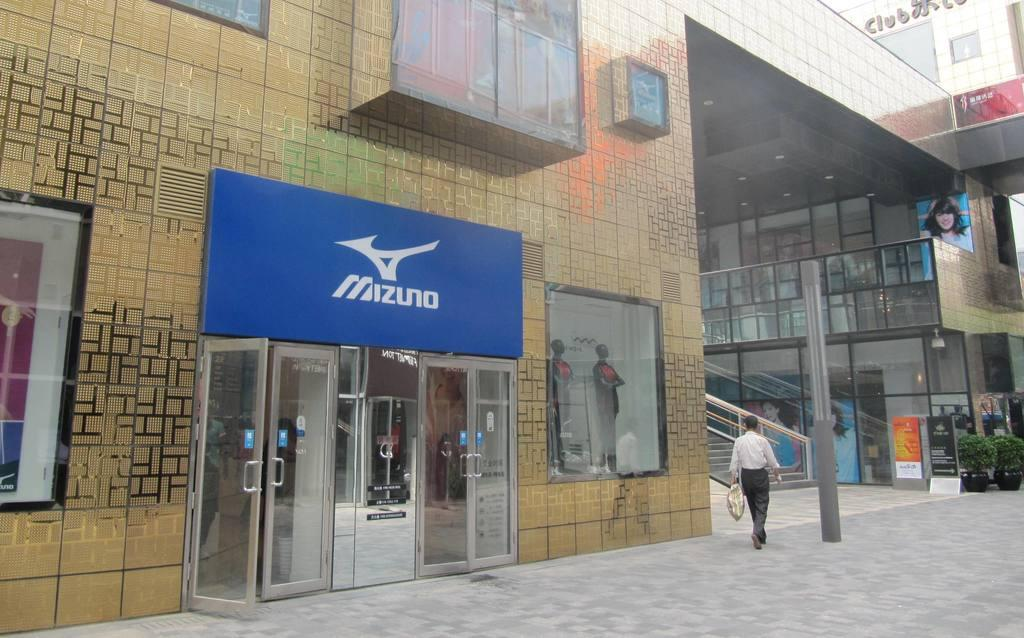What type of structure is visible in the image? There is a building in the image. What type of entrance can be seen in the building? There are glass doors in the image. What materials are present in the image? There are boards, glass fencing, and a pole visible in the image. What objects are present in the building? There are mannequins in the image. Are there any architectural features in the image? Yes, there are stairs in the image. What is the person in the image doing? A person is walking in the image and holding something. What type of muscle is visible on the mannequins in the image? The mannequins in the image are inanimate objects and do not have muscles. 